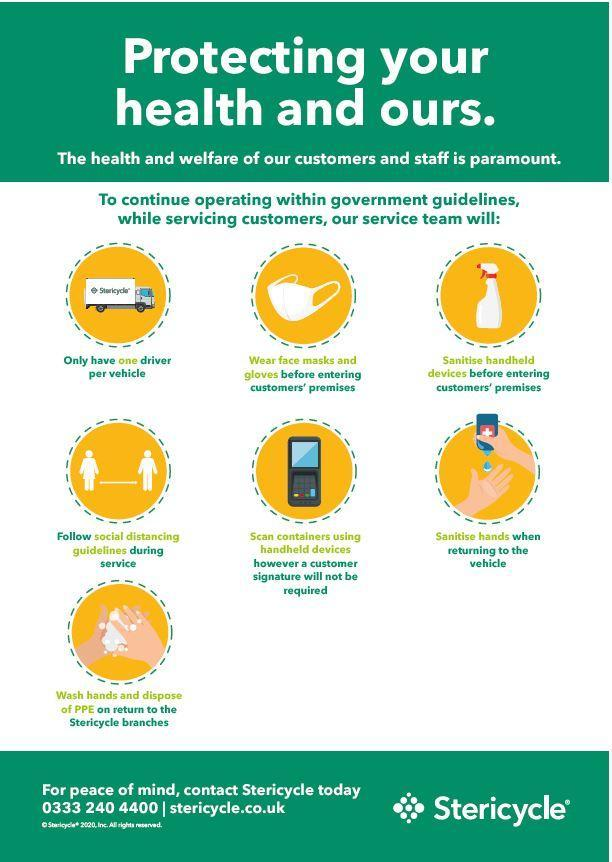How many masks are shown in this infographic image?
Answer the question with a short phrase. 1 